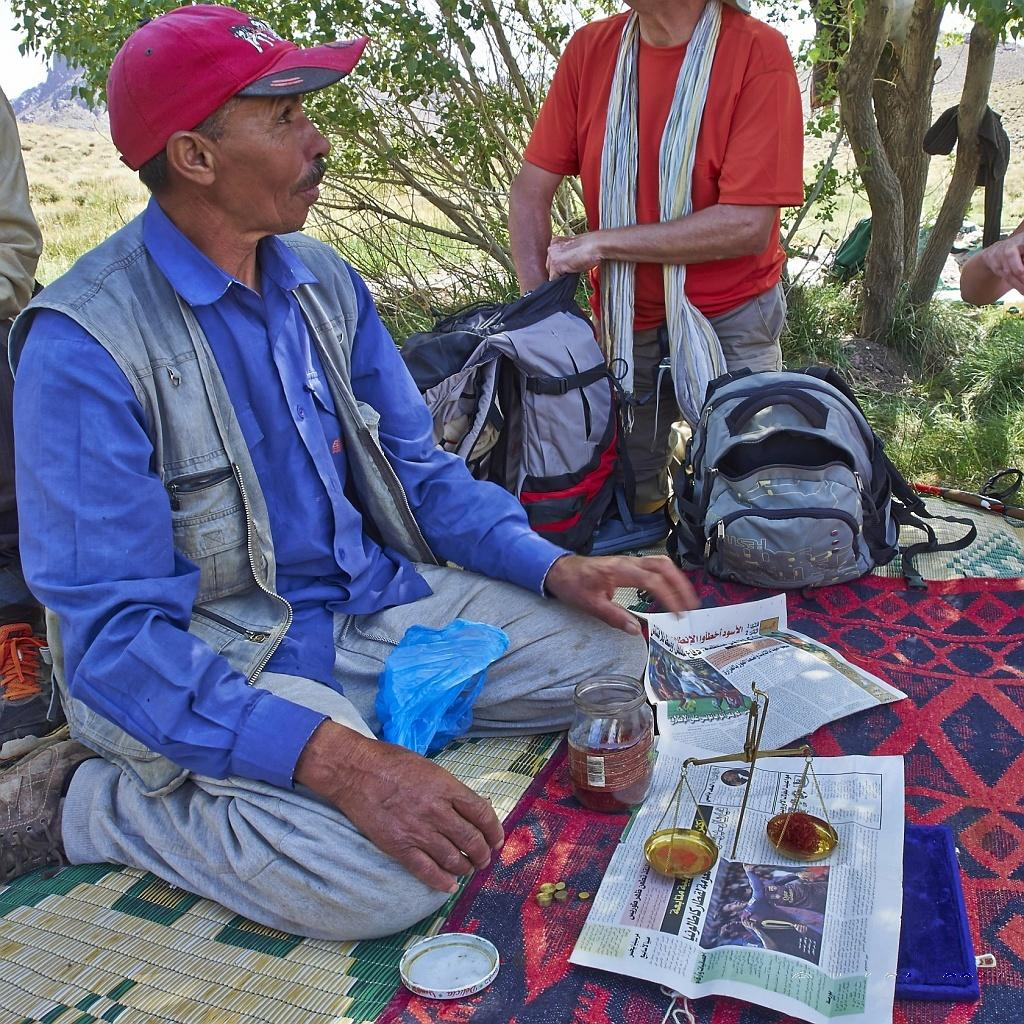What are the people in the image doing? The people in the image are seated on the ground. What objects are in front of the people? Papers, bottles, and baggage are visible in front of the people. What can be seen in the background of the image? There are trees in the background of the image. What type of lift can be seen in the image? There is no lift present in the image. How does the image reflect the people's state of mind? The image does not provide any information about the people's state of mind. 